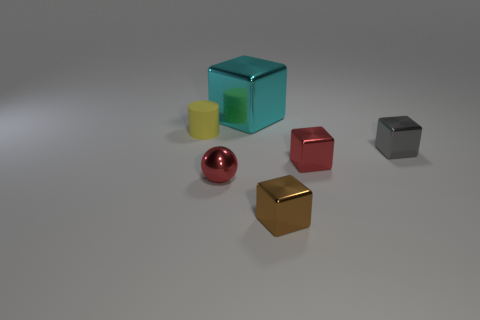Subtract 1 blocks. How many blocks are left? 3 Add 2 big yellow matte blocks. How many objects exist? 8 Subtract all spheres. How many objects are left? 5 Subtract all purple matte objects. Subtract all tiny brown blocks. How many objects are left? 5 Add 4 tiny gray things. How many tiny gray things are left? 5 Add 3 tiny yellow rubber cylinders. How many tiny yellow rubber cylinders exist? 4 Subtract 0 gray balls. How many objects are left? 6 